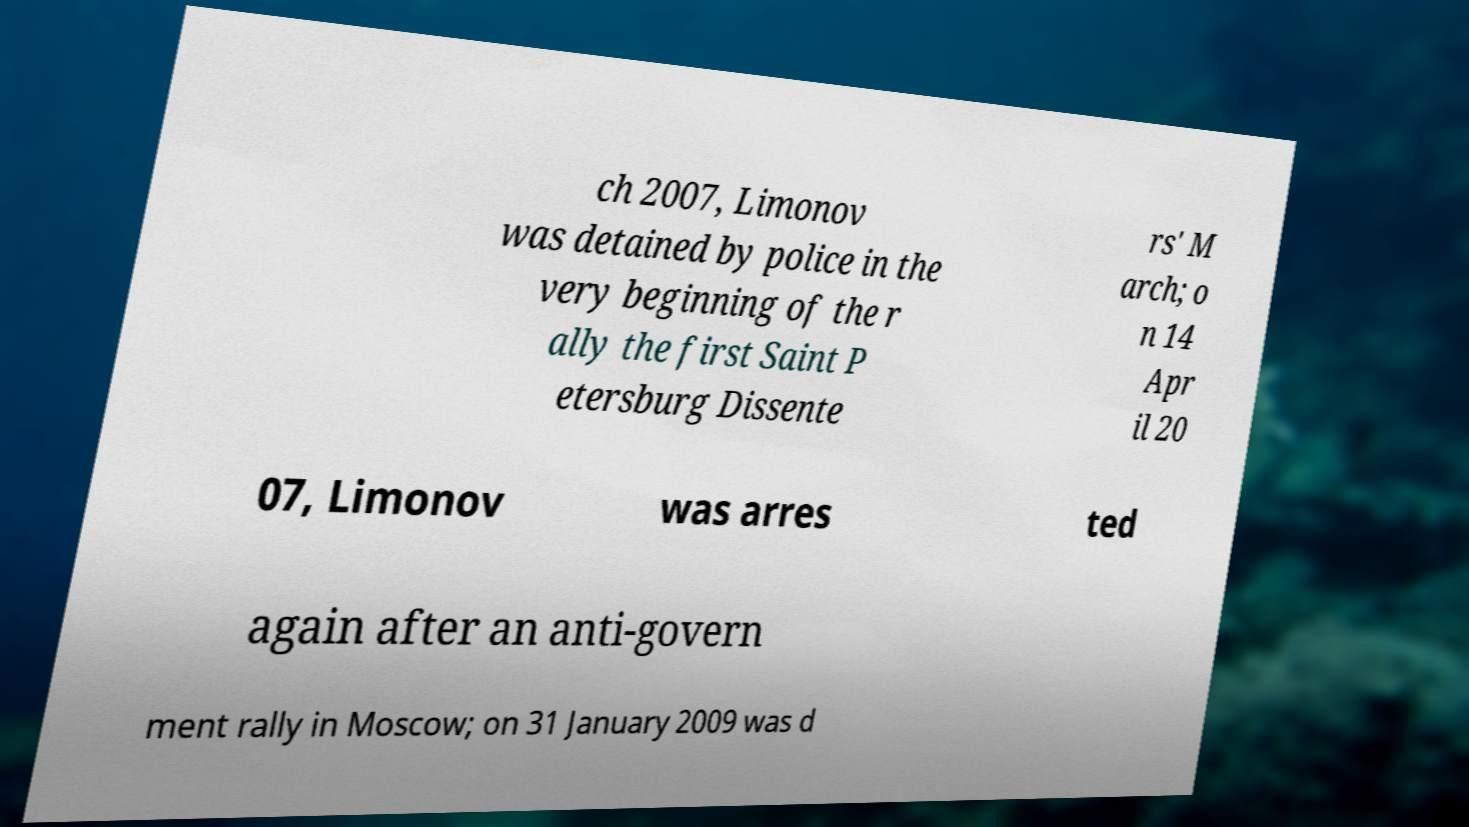Can you accurately transcribe the text from the provided image for me? ch 2007, Limonov was detained by police in the very beginning of the r ally the first Saint P etersburg Dissente rs' M arch; o n 14 Apr il 20 07, Limonov was arres ted again after an anti-govern ment rally in Moscow; on 31 January 2009 was d 